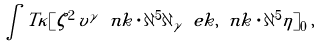<formula> <loc_0><loc_0><loc_500><loc_500>\int T \kappa [ \zeta ^ { 2 } \, \tilde { v } ^ { \gamma } \ n k \cdot \partial ^ { 5 } \partial _ { \gamma } \ e k , \ n k \cdot \partial ^ { 5 } \tilde { \eta } ] _ { 0 } \, ,</formula> 